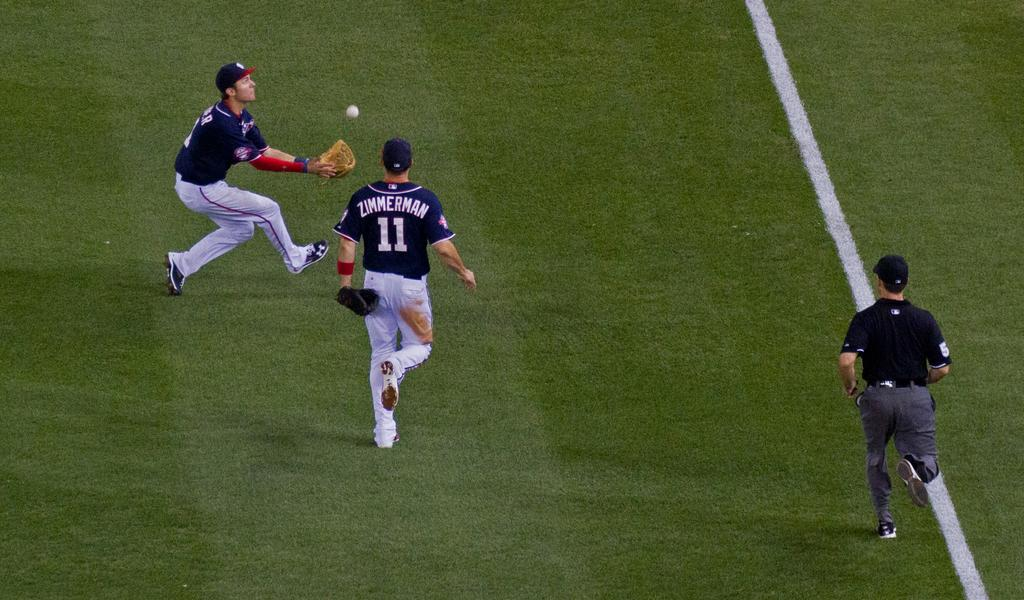<image>
Describe the image concisely. a player that has the name Zimmerman on their jersey 